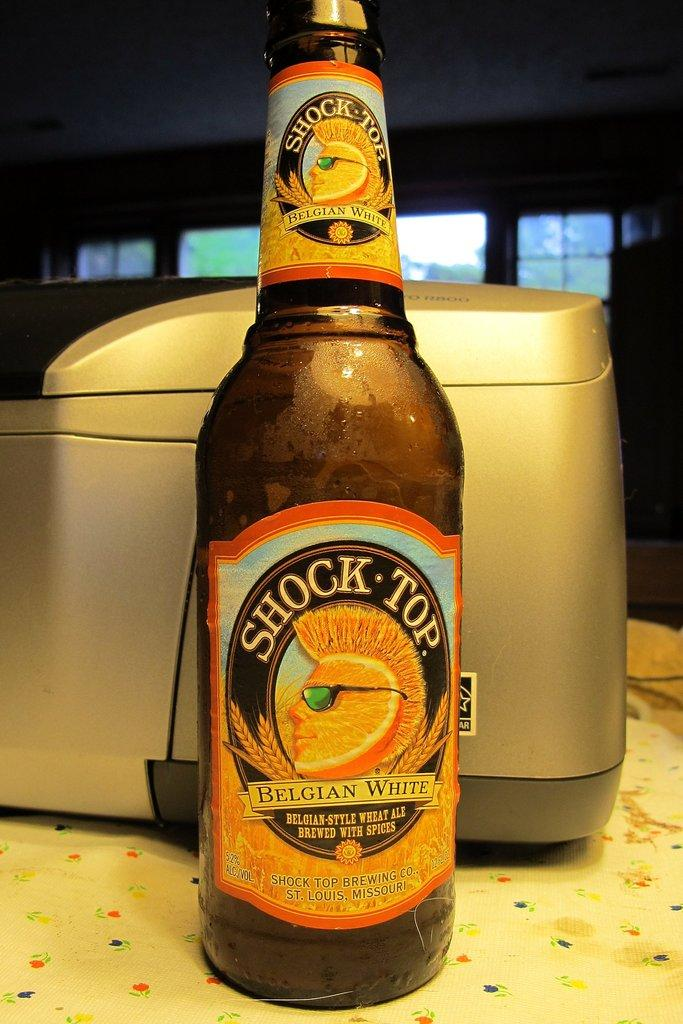<image>
Give a short and clear explanation of the subsequent image. A bottle Shock Top Belgian White Beer is sitting on counter in front of an apppliance. 